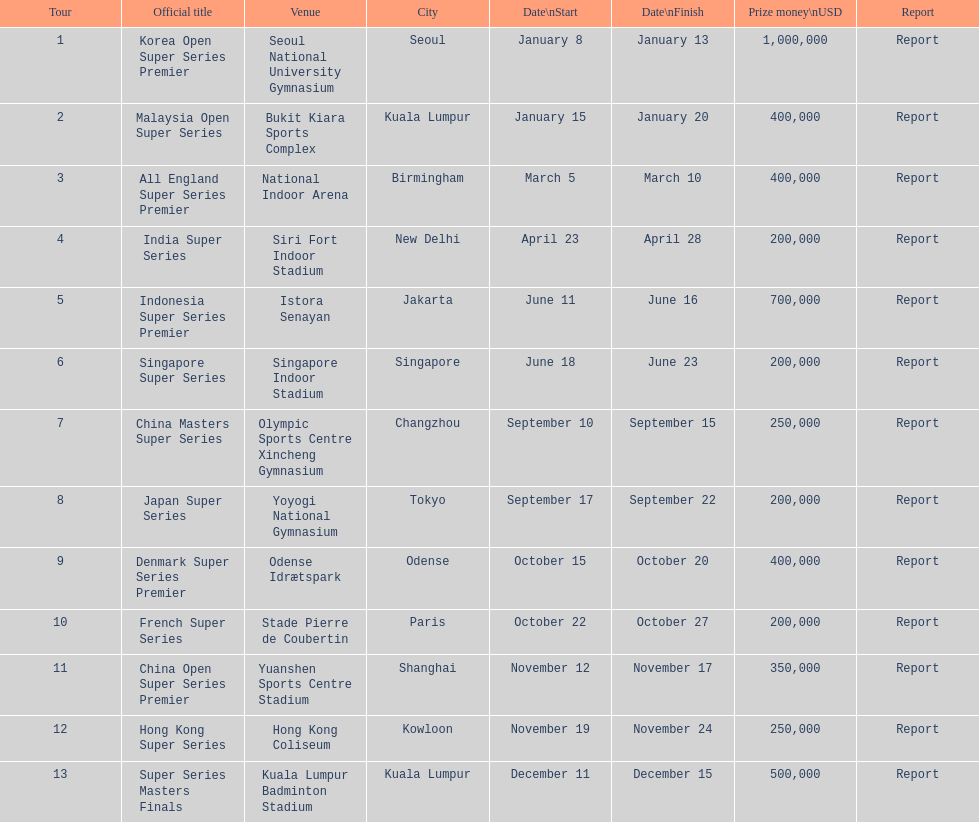How many occur in the last six months of the year? 7. 